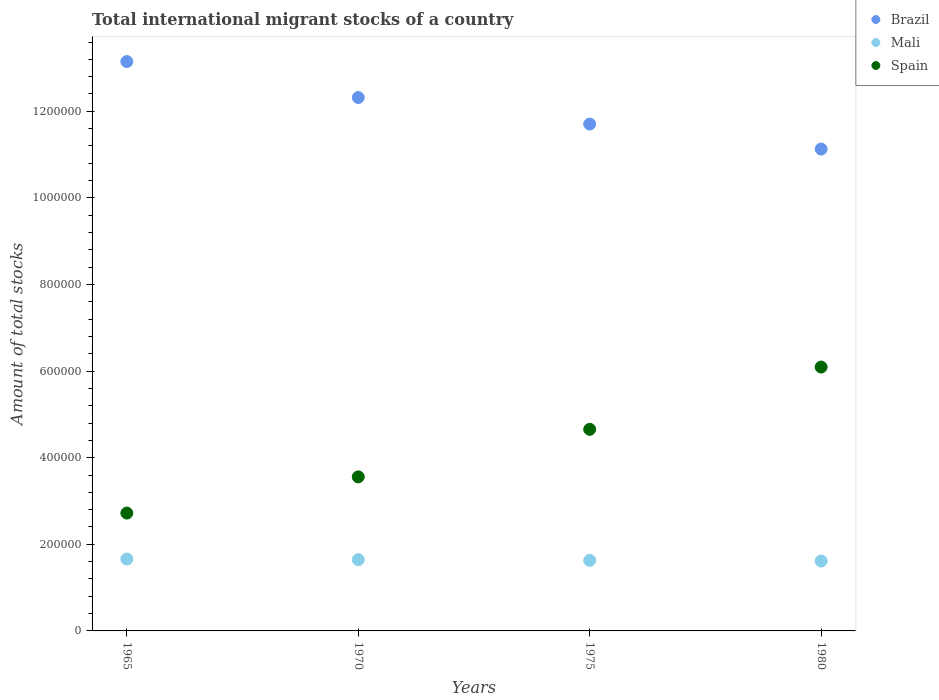What is the amount of total stocks in in Spain in 1970?
Your response must be concise. 3.56e+05. Across all years, what is the maximum amount of total stocks in in Mali?
Offer a terse response. 1.66e+05. Across all years, what is the minimum amount of total stocks in in Mali?
Keep it short and to the point. 1.62e+05. In which year was the amount of total stocks in in Spain minimum?
Your answer should be compact. 1965. What is the total amount of total stocks in in Mali in the graph?
Your response must be concise. 6.55e+05. What is the difference between the amount of total stocks in in Mali in 1970 and that in 1980?
Give a very brief answer. 3017. What is the difference between the amount of total stocks in in Brazil in 1980 and the amount of total stocks in in Spain in 1970?
Ensure brevity in your answer.  7.57e+05. What is the average amount of total stocks in in Spain per year?
Provide a succinct answer. 4.26e+05. In the year 1965, what is the difference between the amount of total stocks in in Brazil and amount of total stocks in in Mali?
Your answer should be compact. 1.15e+06. In how many years, is the amount of total stocks in in Spain greater than 280000?
Offer a very short reply. 3. What is the ratio of the amount of total stocks in in Spain in 1965 to that in 1980?
Keep it short and to the point. 0.45. What is the difference between the highest and the second highest amount of total stocks in in Spain?
Provide a succinct answer. 1.44e+05. What is the difference between the highest and the lowest amount of total stocks in in Mali?
Ensure brevity in your answer.  4547. In how many years, is the amount of total stocks in in Brazil greater than the average amount of total stocks in in Brazil taken over all years?
Ensure brevity in your answer.  2. Is the sum of the amount of total stocks in in Brazil in 1965 and 1975 greater than the maximum amount of total stocks in in Spain across all years?
Provide a short and direct response. Yes. Does the amount of total stocks in in Spain monotonically increase over the years?
Offer a very short reply. Yes. How many dotlines are there?
Your response must be concise. 3. What is the difference between two consecutive major ticks on the Y-axis?
Provide a short and direct response. 2.00e+05. Are the values on the major ticks of Y-axis written in scientific E-notation?
Your response must be concise. No. What is the title of the graph?
Keep it short and to the point. Total international migrant stocks of a country. What is the label or title of the X-axis?
Keep it short and to the point. Years. What is the label or title of the Y-axis?
Provide a short and direct response. Amount of total stocks. What is the Amount of total stocks of Brazil in 1965?
Make the answer very short. 1.31e+06. What is the Amount of total stocks of Mali in 1965?
Ensure brevity in your answer.  1.66e+05. What is the Amount of total stocks in Spain in 1965?
Your response must be concise. 2.72e+05. What is the Amount of total stocks of Brazil in 1970?
Your response must be concise. 1.23e+06. What is the Amount of total stocks in Mali in 1970?
Offer a very short reply. 1.65e+05. What is the Amount of total stocks in Spain in 1970?
Offer a terse response. 3.56e+05. What is the Amount of total stocks in Brazil in 1975?
Ensure brevity in your answer.  1.17e+06. What is the Amount of total stocks in Mali in 1975?
Your response must be concise. 1.63e+05. What is the Amount of total stocks in Spain in 1975?
Offer a very short reply. 4.66e+05. What is the Amount of total stocks in Brazil in 1980?
Provide a succinct answer. 1.11e+06. What is the Amount of total stocks in Mali in 1980?
Offer a terse response. 1.62e+05. What is the Amount of total stocks of Spain in 1980?
Ensure brevity in your answer.  6.09e+05. Across all years, what is the maximum Amount of total stocks of Brazil?
Give a very brief answer. 1.31e+06. Across all years, what is the maximum Amount of total stocks of Mali?
Your answer should be very brief. 1.66e+05. Across all years, what is the maximum Amount of total stocks of Spain?
Your answer should be compact. 6.09e+05. Across all years, what is the minimum Amount of total stocks in Brazil?
Your response must be concise. 1.11e+06. Across all years, what is the minimum Amount of total stocks in Mali?
Make the answer very short. 1.62e+05. Across all years, what is the minimum Amount of total stocks in Spain?
Keep it short and to the point. 2.72e+05. What is the total Amount of total stocks of Brazil in the graph?
Offer a terse response. 4.83e+06. What is the total Amount of total stocks of Mali in the graph?
Your answer should be very brief. 6.55e+05. What is the total Amount of total stocks of Spain in the graph?
Keep it short and to the point. 1.70e+06. What is the difference between the Amount of total stocks in Brazil in 1965 and that in 1970?
Your answer should be very brief. 8.31e+04. What is the difference between the Amount of total stocks of Mali in 1965 and that in 1970?
Provide a succinct answer. 1530. What is the difference between the Amount of total stocks of Spain in 1965 and that in 1970?
Make the answer very short. -8.35e+04. What is the difference between the Amount of total stocks in Brazil in 1965 and that in 1975?
Ensure brevity in your answer.  1.44e+05. What is the difference between the Amount of total stocks of Mali in 1965 and that in 1975?
Your response must be concise. 3045. What is the difference between the Amount of total stocks of Spain in 1965 and that in 1975?
Your answer should be very brief. -1.93e+05. What is the difference between the Amount of total stocks of Brazil in 1965 and that in 1980?
Your answer should be very brief. 2.02e+05. What is the difference between the Amount of total stocks of Mali in 1965 and that in 1980?
Make the answer very short. 4547. What is the difference between the Amount of total stocks in Spain in 1965 and that in 1980?
Give a very brief answer. -3.37e+05. What is the difference between the Amount of total stocks of Brazil in 1970 and that in 1975?
Ensure brevity in your answer.  6.13e+04. What is the difference between the Amount of total stocks in Mali in 1970 and that in 1975?
Make the answer very short. 1515. What is the difference between the Amount of total stocks of Spain in 1970 and that in 1975?
Make the answer very short. -1.10e+05. What is the difference between the Amount of total stocks in Brazil in 1970 and that in 1980?
Offer a terse response. 1.19e+05. What is the difference between the Amount of total stocks in Mali in 1970 and that in 1980?
Your response must be concise. 3017. What is the difference between the Amount of total stocks of Spain in 1970 and that in 1980?
Your response must be concise. -2.54e+05. What is the difference between the Amount of total stocks of Brazil in 1975 and that in 1980?
Give a very brief answer. 5.77e+04. What is the difference between the Amount of total stocks in Mali in 1975 and that in 1980?
Offer a very short reply. 1502. What is the difference between the Amount of total stocks of Spain in 1975 and that in 1980?
Offer a terse response. -1.44e+05. What is the difference between the Amount of total stocks in Brazil in 1965 and the Amount of total stocks in Mali in 1970?
Provide a short and direct response. 1.15e+06. What is the difference between the Amount of total stocks of Brazil in 1965 and the Amount of total stocks of Spain in 1970?
Your answer should be very brief. 9.59e+05. What is the difference between the Amount of total stocks in Mali in 1965 and the Amount of total stocks in Spain in 1970?
Provide a short and direct response. -1.90e+05. What is the difference between the Amount of total stocks in Brazil in 1965 and the Amount of total stocks in Mali in 1975?
Offer a very short reply. 1.15e+06. What is the difference between the Amount of total stocks of Brazil in 1965 and the Amount of total stocks of Spain in 1975?
Your response must be concise. 8.49e+05. What is the difference between the Amount of total stocks of Mali in 1965 and the Amount of total stocks of Spain in 1975?
Offer a terse response. -2.99e+05. What is the difference between the Amount of total stocks in Brazil in 1965 and the Amount of total stocks in Mali in 1980?
Keep it short and to the point. 1.15e+06. What is the difference between the Amount of total stocks of Brazil in 1965 and the Amount of total stocks of Spain in 1980?
Provide a succinct answer. 7.06e+05. What is the difference between the Amount of total stocks in Mali in 1965 and the Amount of total stocks in Spain in 1980?
Give a very brief answer. -4.43e+05. What is the difference between the Amount of total stocks of Brazil in 1970 and the Amount of total stocks of Mali in 1975?
Make the answer very short. 1.07e+06. What is the difference between the Amount of total stocks in Brazil in 1970 and the Amount of total stocks in Spain in 1975?
Give a very brief answer. 7.66e+05. What is the difference between the Amount of total stocks in Mali in 1970 and the Amount of total stocks in Spain in 1975?
Offer a very short reply. -3.01e+05. What is the difference between the Amount of total stocks in Brazil in 1970 and the Amount of total stocks in Mali in 1980?
Your answer should be compact. 1.07e+06. What is the difference between the Amount of total stocks of Brazil in 1970 and the Amount of total stocks of Spain in 1980?
Make the answer very short. 6.22e+05. What is the difference between the Amount of total stocks of Mali in 1970 and the Amount of total stocks of Spain in 1980?
Your answer should be very brief. -4.45e+05. What is the difference between the Amount of total stocks of Brazil in 1975 and the Amount of total stocks of Mali in 1980?
Offer a very short reply. 1.01e+06. What is the difference between the Amount of total stocks of Brazil in 1975 and the Amount of total stocks of Spain in 1980?
Your answer should be compact. 5.61e+05. What is the difference between the Amount of total stocks of Mali in 1975 and the Amount of total stocks of Spain in 1980?
Keep it short and to the point. -4.46e+05. What is the average Amount of total stocks of Brazil per year?
Your response must be concise. 1.21e+06. What is the average Amount of total stocks in Mali per year?
Keep it short and to the point. 1.64e+05. What is the average Amount of total stocks of Spain per year?
Your answer should be compact. 4.26e+05. In the year 1965, what is the difference between the Amount of total stocks in Brazil and Amount of total stocks in Mali?
Your response must be concise. 1.15e+06. In the year 1965, what is the difference between the Amount of total stocks of Brazil and Amount of total stocks of Spain?
Ensure brevity in your answer.  1.04e+06. In the year 1965, what is the difference between the Amount of total stocks of Mali and Amount of total stocks of Spain?
Your response must be concise. -1.06e+05. In the year 1970, what is the difference between the Amount of total stocks of Brazil and Amount of total stocks of Mali?
Ensure brevity in your answer.  1.07e+06. In the year 1970, what is the difference between the Amount of total stocks of Brazil and Amount of total stocks of Spain?
Your answer should be compact. 8.76e+05. In the year 1970, what is the difference between the Amount of total stocks in Mali and Amount of total stocks in Spain?
Make the answer very short. -1.91e+05. In the year 1975, what is the difference between the Amount of total stocks of Brazil and Amount of total stocks of Mali?
Your response must be concise. 1.01e+06. In the year 1975, what is the difference between the Amount of total stocks in Brazil and Amount of total stocks in Spain?
Provide a succinct answer. 7.05e+05. In the year 1975, what is the difference between the Amount of total stocks in Mali and Amount of total stocks in Spain?
Provide a succinct answer. -3.03e+05. In the year 1980, what is the difference between the Amount of total stocks in Brazil and Amount of total stocks in Mali?
Ensure brevity in your answer.  9.51e+05. In the year 1980, what is the difference between the Amount of total stocks in Brazil and Amount of total stocks in Spain?
Your response must be concise. 5.03e+05. In the year 1980, what is the difference between the Amount of total stocks in Mali and Amount of total stocks in Spain?
Offer a terse response. -4.48e+05. What is the ratio of the Amount of total stocks of Brazil in 1965 to that in 1970?
Give a very brief answer. 1.07. What is the ratio of the Amount of total stocks in Mali in 1965 to that in 1970?
Make the answer very short. 1.01. What is the ratio of the Amount of total stocks in Spain in 1965 to that in 1970?
Provide a succinct answer. 0.77. What is the ratio of the Amount of total stocks in Brazil in 1965 to that in 1975?
Your response must be concise. 1.12. What is the ratio of the Amount of total stocks of Mali in 1965 to that in 1975?
Offer a terse response. 1.02. What is the ratio of the Amount of total stocks in Spain in 1965 to that in 1975?
Provide a short and direct response. 0.58. What is the ratio of the Amount of total stocks of Brazil in 1965 to that in 1980?
Give a very brief answer. 1.18. What is the ratio of the Amount of total stocks in Mali in 1965 to that in 1980?
Provide a short and direct response. 1.03. What is the ratio of the Amount of total stocks of Spain in 1965 to that in 1980?
Make the answer very short. 0.45. What is the ratio of the Amount of total stocks in Brazil in 1970 to that in 1975?
Your answer should be compact. 1.05. What is the ratio of the Amount of total stocks of Mali in 1970 to that in 1975?
Provide a succinct answer. 1.01. What is the ratio of the Amount of total stocks of Spain in 1970 to that in 1975?
Offer a very short reply. 0.76. What is the ratio of the Amount of total stocks of Brazil in 1970 to that in 1980?
Give a very brief answer. 1.11. What is the ratio of the Amount of total stocks of Mali in 1970 to that in 1980?
Give a very brief answer. 1.02. What is the ratio of the Amount of total stocks of Spain in 1970 to that in 1980?
Your answer should be compact. 0.58. What is the ratio of the Amount of total stocks of Brazil in 1975 to that in 1980?
Offer a very short reply. 1.05. What is the ratio of the Amount of total stocks of Mali in 1975 to that in 1980?
Provide a short and direct response. 1.01. What is the ratio of the Amount of total stocks in Spain in 1975 to that in 1980?
Offer a terse response. 0.76. What is the difference between the highest and the second highest Amount of total stocks of Brazil?
Give a very brief answer. 8.31e+04. What is the difference between the highest and the second highest Amount of total stocks of Mali?
Keep it short and to the point. 1530. What is the difference between the highest and the second highest Amount of total stocks of Spain?
Ensure brevity in your answer.  1.44e+05. What is the difference between the highest and the lowest Amount of total stocks in Brazil?
Give a very brief answer. 2.02e+05. What is the difference between the highest and the lowest Amount of total stocks of Mali?
Your response must be concise. 4547. What is the difference between the highest and the lowest Amount of total stocks of Spain?
Provide a short and direct response. 3.37e+05. 